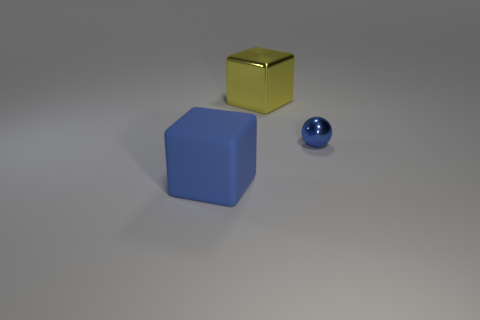Add 3 cyan metallic spheres. How many objects exist? 6 Subtract all spheres. How many objects are left? 2 Subtract 0 yellow cylinders. How many objects are left? 3 Subtract all big red objects. Subtract all small objects. How many objects are left? 2 Add 3 big yellow blocks. How many big yellow blocks are left? 4 Add 2 tiny metal balls. How many tiny metal balls exist? 3 